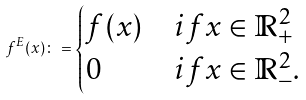<formula> <loc_0><loc_0><loc_500><loc_500>f ^ { E } ( x ) \colon = \begin{cases} f ( x ) & i f x \in \mathbb { R } ^ { 2 } _ { + } \\ 0 & i f x \in \mathbb { R } ^ { 2 } _ { - } . \end{cases}</formula> 